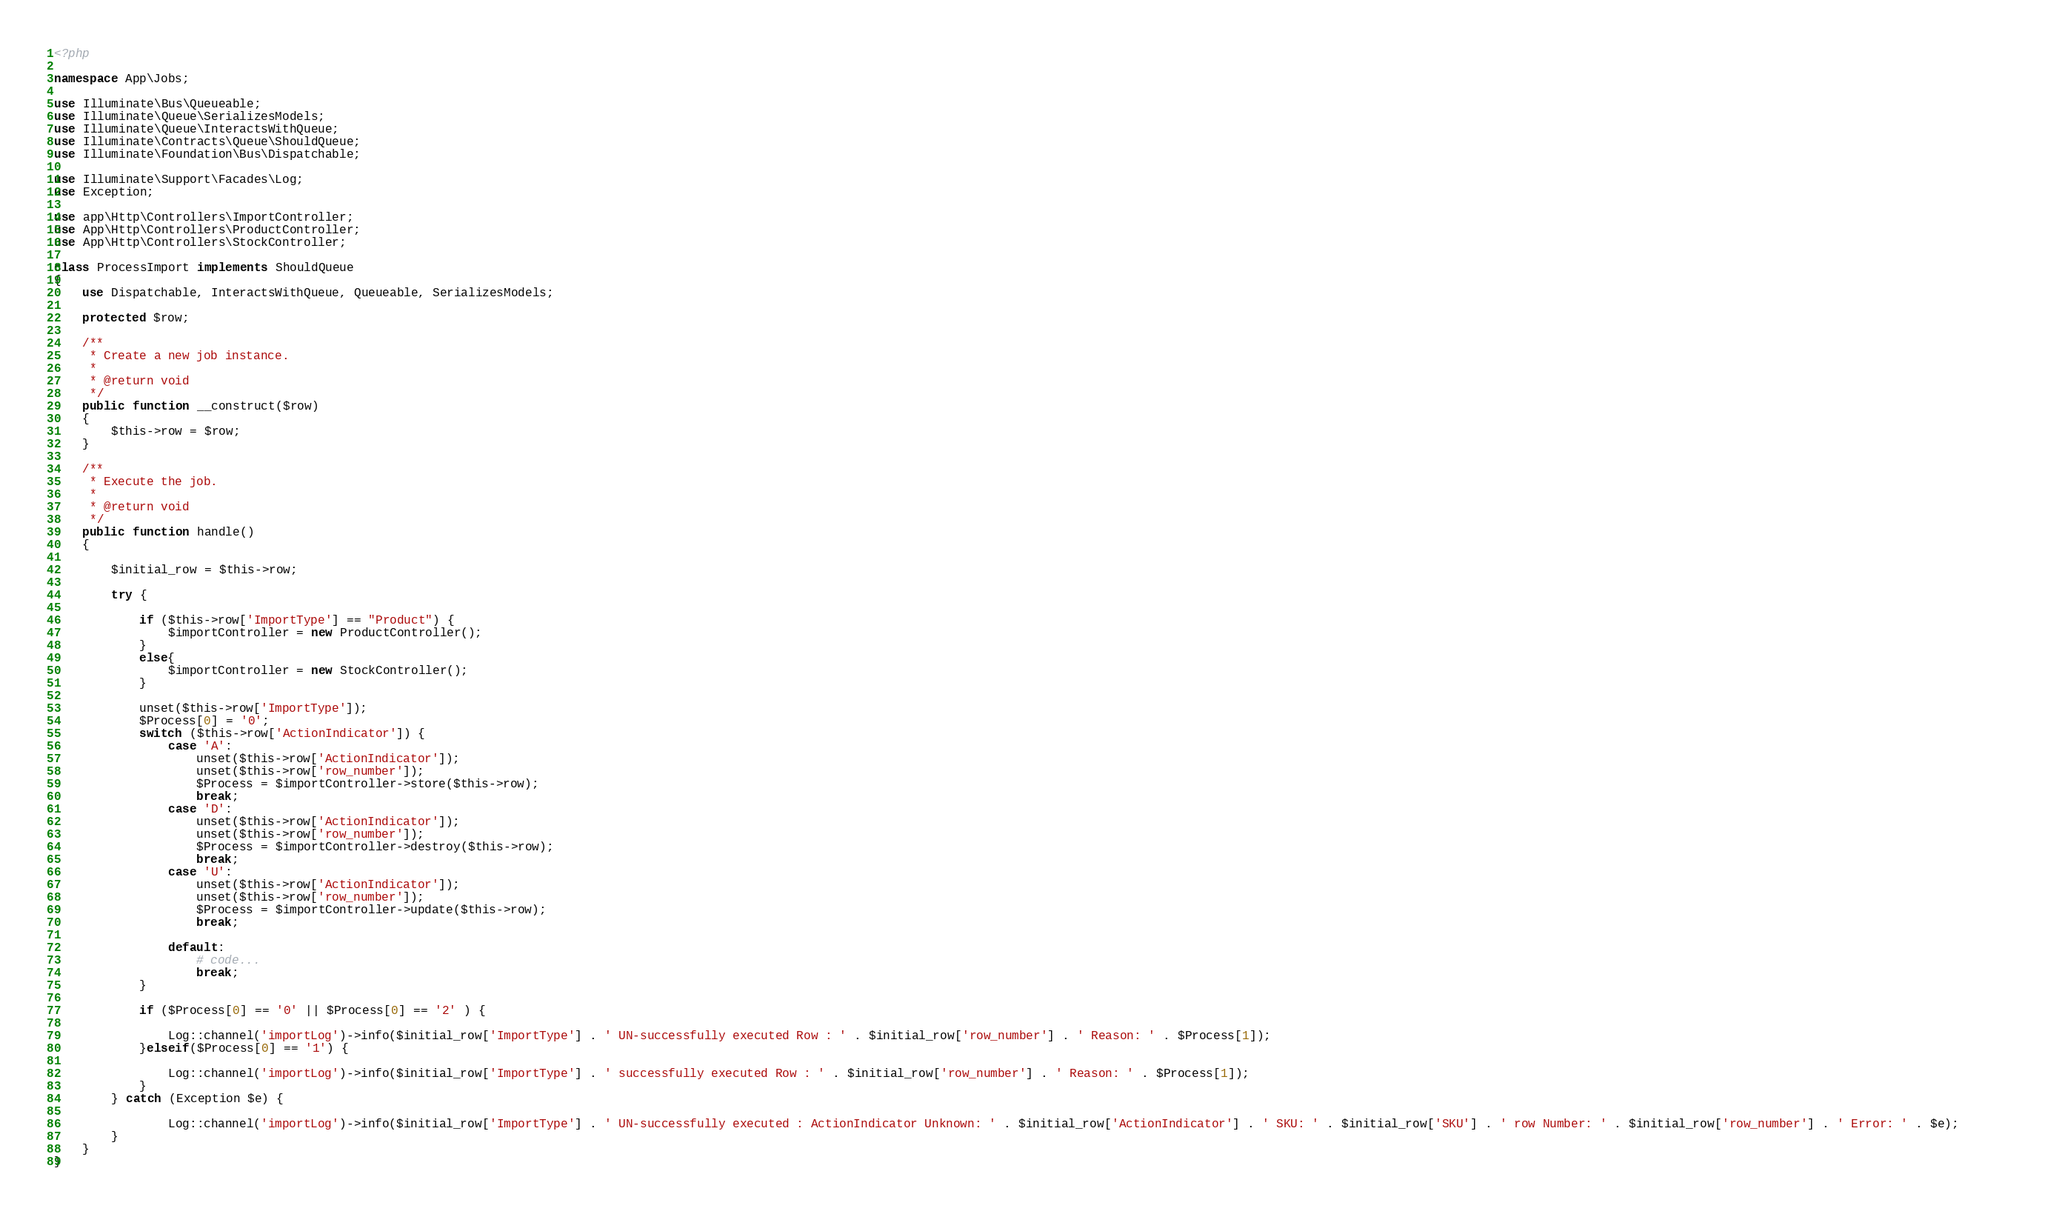Convert code to text. <code><loc_0><loc_0><loc_500><loc_500><_PHP_><?php

namespace App\Jobs;

use Illuminate\Bus\Queueable;
use Illuminate\Queue\SerializesModels;
use Illuminate\Queue\InteractsWithQueue;
use Illuminate\Contracts\Queue\ShouldQueue;
use Illuminate\Foundation\Bus\Dispatchable;

use Illuminate\Support\Facades\Log;
use Exception;

use app\Http\Controllers\ImportController;
use App\Http\Controllers\ProductController;
use App\Http\Controllers\StockController;

class ProcessImport implements ShouldQueue
{
    use Dispatchable, InteractsWithQueue, Queueable, SerializesModels;

    protected $row;

    /**
     * Create a new job instance.
     *
     * @return void
     */
    public function __construct($row)
    {
        $this->row = $row;
    }

    /**
     * Execute the job.
     *
     * @return void
     */
    public function handle()
    {
 
        $initial_row = $this->row;

        try {
            
            if ($this->row['ImportType'] == "Product") {
                $importController = new ProductController();
            }
            else{
                $importController = new StockController();
            }

            unset($this->row['ImportType']);
            $Process[0] = '0';
            switch ($this->row['ActionIndicator']) {
                case 'A':
                    unset($this->row['ActionIndicator']);
                    unset($this->row['row_number']);
                    $Process = $importController->store($this->row);
                    break;
                case 'D':
                    unset($this->row['ActionIndicator']);
                    unset($this->row['row_number']);
                    $Process = $importController->destroy($this->row);
                    break;
                case 'U':
                    unset($this->row['ActionIndicator']);
                    unset($this->row['row_number']);
                    $Process = $importController->update($this->row);
                    break;
                
                default:
                    # code...
                    break;
            }

            if ($Process[0] == '0' || $Process[0] == '2' ) {

                Log::channel('importLog')->info($initial_row['ImportType'] . ' UN-successfully executed Row : ' . $initial_row['row_number'] . ' Reason: ' . $Process[1]);      
            }elseif($Process[0] == '1') {       

                Log::channel('importLog')->info($initial_row['ImportType'] . ' successfully executed Row : ' . $initial_row['row_number'] . ' Reason: ' . $Process[1]);
            }
        } catch (Exception $e) {      

                Log::channel('importLog')->info($initial_row['ImportType'] . ' UN-successfully executed : ActionIndicator Unknown: ' . $initial_row['ActionIndicator'] . ' SKU: ' . $initial_row['SKU'] . ' row Number: ' . $initial_row['row_number'] . ' Error: ' . $e);      
        }
    }
}
</code> 